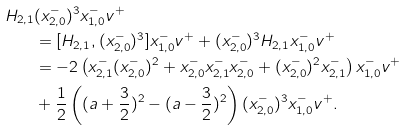<formula> <loc_0><loc_0><loc_500><loc_500>H _ { 2 , 1 } & ( x _ { 2 , 0 } ^ { - } ) ^ { 3 } x _ { 1 , 0 } ^ { - } v ^ { + } \\ & = [ H _ { 2 , 1 } , ( x _ { 2 , 0 } ^ { - } ) ^ { 3 } ] x _ { 1 , 0 } ^ { - } v ^ { + } + ( x _ { 2 , 0 } ^ { - } ) ^ { 3 } H _ { 2 , 1 } x _ { 1 , 0 } ^ { - } v ^ { + } \\ & = - 2 \left ( x _ { 2 , 1 } ^ { - } ( x _ { 2 , 0 } ^ { - } ) ^ { 2 } + x _ { 2 , 0 } ^ { - } x _ { 2 , 1 } ^ { - } x _ { 2 , 0 } ^ { - } + ( x _ { 2 , 0 } ^ { - } ) ^ { 2 } x _ { 2 , 1 } ^ { - } \right ) x _ { 1 , 0 } ^ { - } v ^ { + } \\ & + \frac { 1 } { 2 } \left ( ( a + \frac { 3 } { 2 } ) ^ { 2 } - ( a - \frac { 3 } { 2 } ) ^ { 2 } \right ) ( x _ { 2 , 0 } ^ { - } ) ^ { 3 } x _ { 1 , 0 } ^ { - } v ^ { + } .</formula> 